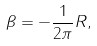Convert formula to latex. <formula><loc_0><loc_0><loc_500><loc_500>\beta = - \frac { 1 } { 2 \pi } R ,</formula> 